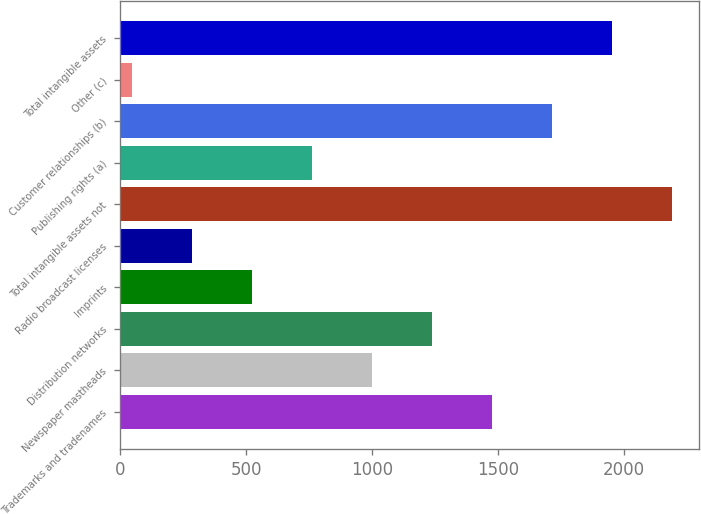<chart> <loc_0><loc_0><loc_500><loc_500><bar_chart><fcel>Trademarks and tradenames<fcel>Newspaper mastheads<fcel>Distribution networks<fcel>Imprints<fcel>Radio broadcast licenses<fcel>Total intangible assets not<fcel>Publishing rights (a)<fcel>Customer relationships (b)<fcel>Other (c)<fcel>Total intangible assets<nl><fcel>1474.4<fcel>998.6<fcel>1236.5<fcel>522.8<fcel>284.9<fcel>2188.1<fcel>760.7<fcel>1712.3<fcel>47<fcel>1950.2<nl></chart> 